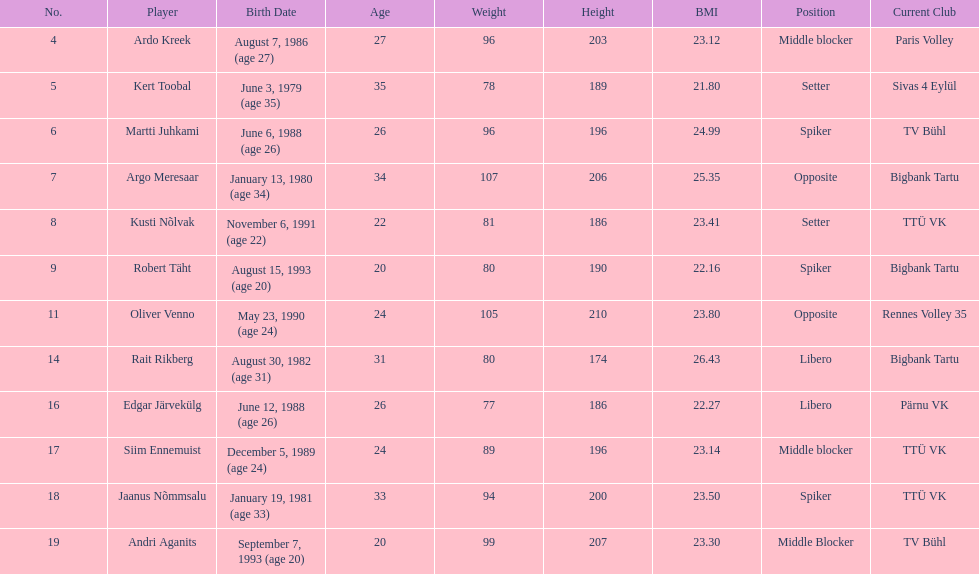How much taller in oliver venno than rait rikberg? 36. 